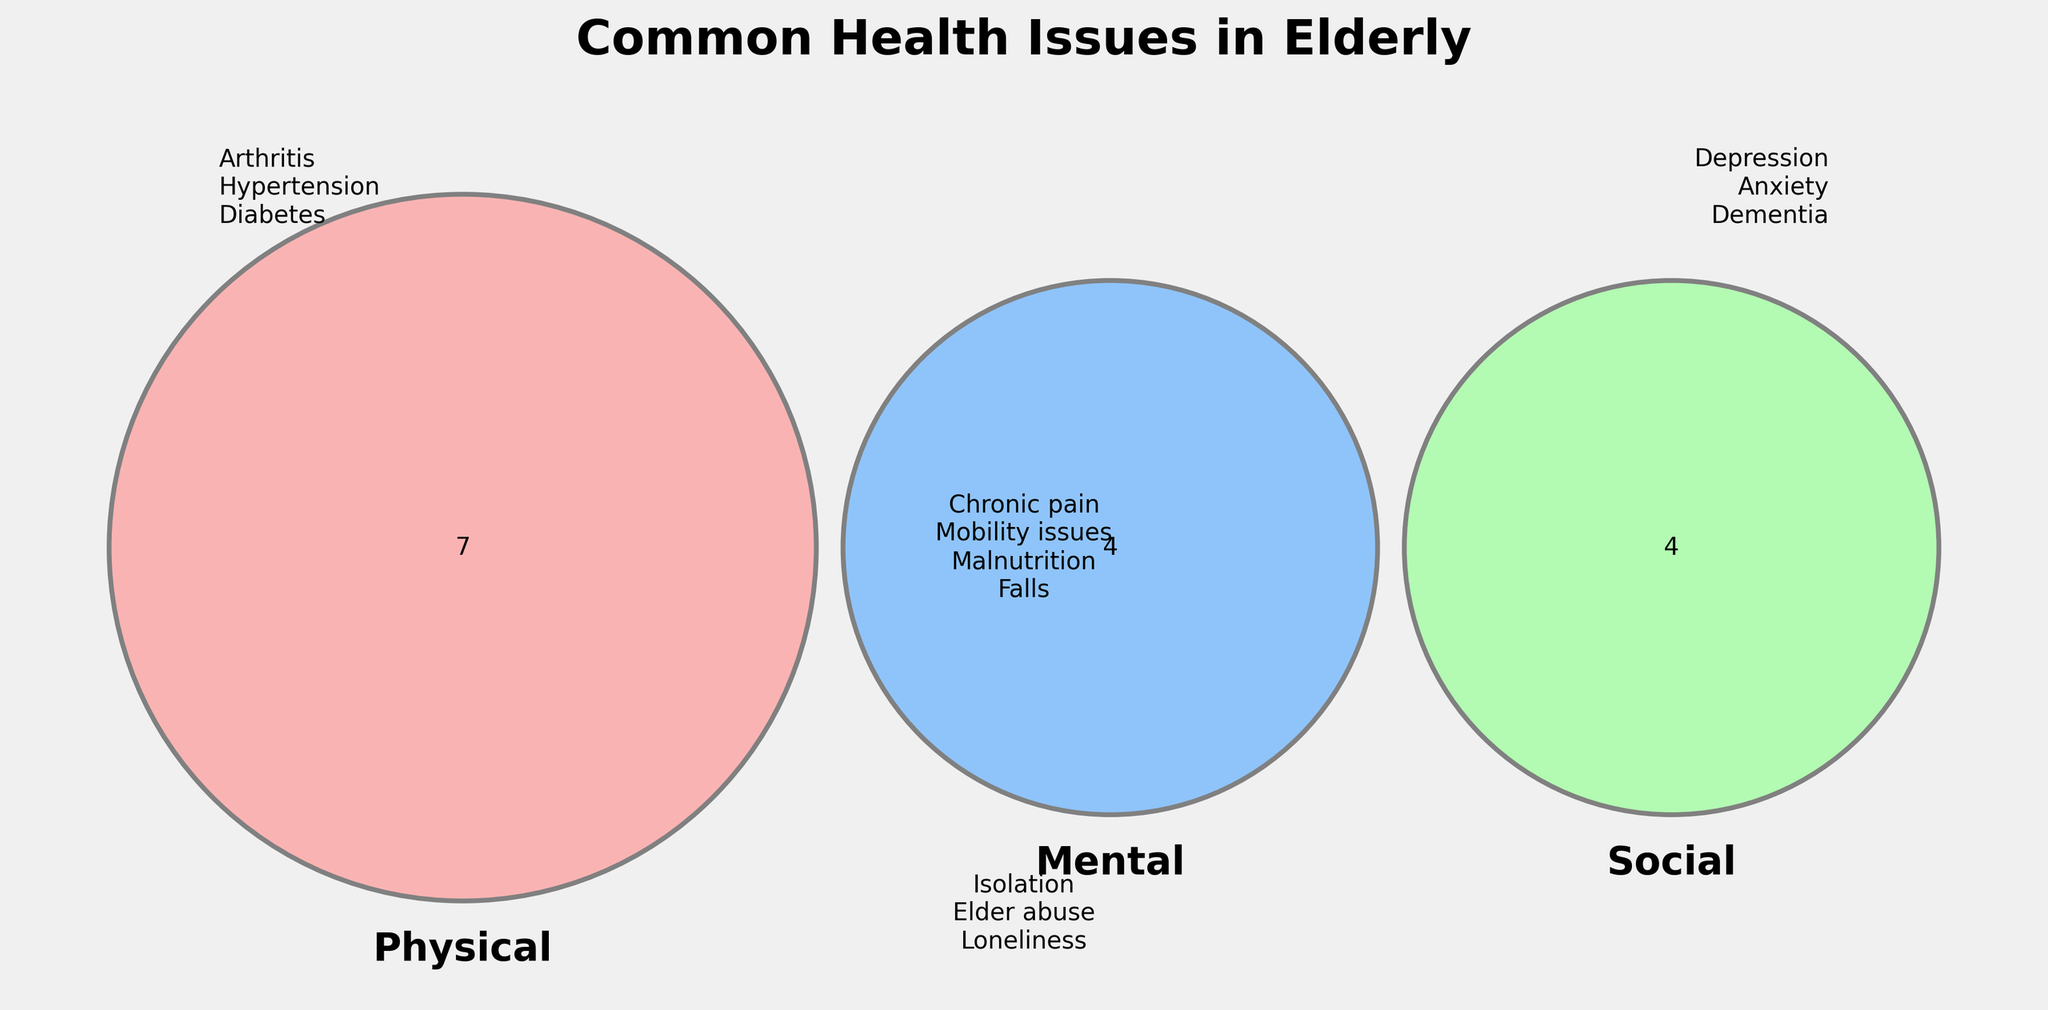What is the title of the diagram? The title is usually at the top of the diagram. Here, it reads "Common Health Issues in Elderly".
Answer: Common Health Issues in Elderly How many categories are represented in the diagram? Each circle in a Venn diagram represents a category. This diagram contains three circles.
Answer: 3 Which physical health issues are listed in the diagram? The text next to the Physical circle represents physical health issues. They are "Arthritis", "Hypertension", "Diabetes", "Osteoporosis", "Hearing loss", "Vision problems", and "Incontinence".
Answer: Arthritis, Hypertension, Diabetes, Osteoporosis, Hearing loss, Vision problems, Incontinence How many overlapping health issues are there, and what are they? The text in the overlapping section of the three circles lists the overlapping health issues. They are "Chronic pain", "Mobility issues", "Malnutrition", and "Falls".
Answer: 4, Chronic pain, Mobility issues, Malnutrition, Falls What mental health issues are listed in the diagram? The text next to the Mental circle represents mental health issues. They are "Depression", "Anxiety", "Dementia", and "Insomnia".
Answer: Depression, Anxiety, Dementia, Insomnia Which social health issue is exclusively mentioned in the diagram? The text next to the Social circle represents social health issues. By examining that list, we see that "Caregiver stress" is only mentioned under that category, without any overlap listed.
Answer: Caregiver stress What are the three categories in the Venn diagram? Each circle is labeled with a category name. These labels are "Physical", "Mental", and "Social".
Answer: Physical, Mental, Social Which category includes "Loneliness"? Check the text next to the circle labeled "Social". "Loneliness" is listed there.
Answer: Social Is "Insomnia" an overlapping issue or unique to one category? "Insomnia" is listed next to the Mental circle and is not part of the overlapping section, thus unique to the mental health category.
Answer: Unique to Mental What physical and social overlapping health issues are shown? Look at the overlap between Physical and Social categories only. "Falls" overlaps between these two categories based on the text in the overlapping section.
Answer: Falls 